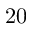Convert formula to latex. <formula><loc_0><loc_0><loc_500><loc_500>2 0</formula> 